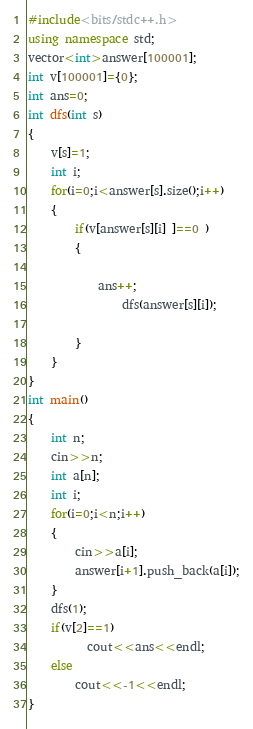<code> <loc_0><loc_0><loc_500><loc_500><_C++_>#include<bits/stdc++.h>
using namespace std;
vector<int>answer[100001];
int v[100001]={0};
int ans=0;
int dfs(int s)
{
    v[s]=1;
    int i;
    for(i=0;i<answer[s].size();i++)
    {
        if(v[answer[s][i] ]==0 )
        {

            ans++;
                dfs(answer[s][i]);

        }
    }
}
int main()
{
    int n;
    cin>>n;
    int a[n];
    int i;
    for(i=0;i<n;i++)
    {
        cin>>a[i];
        answer[i+1].push_back(a[i]);
    }
    dfs(1);
    if(v[2]==1)
          cout<<ans<<endl;
    else
        cout<<-1<<endl;
}
</code> 